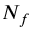<formula> <loc_0><loc_0><loc_500><loc_500>N _ { f }</formula> 